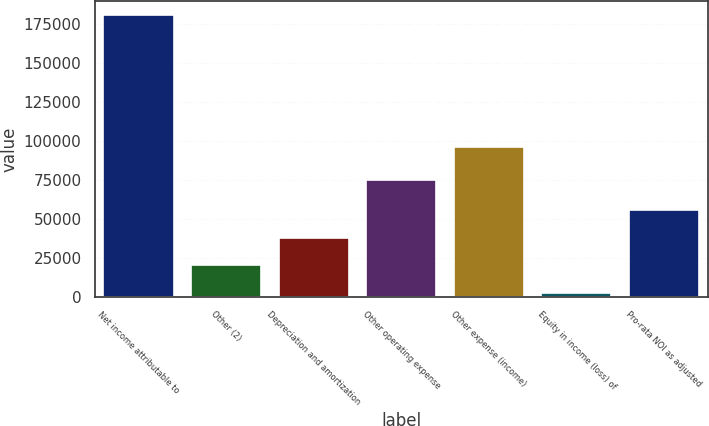Convert chart. <chart><loc_0><loc_0><loc_500><loc_500><bar_chart><fcel>Net income attributable to<fcel>Other (2)<fcel>Depreciation and amortization<fcel>Other operating expense<fcel>Other expense (income)<fcel>Equity in income (loss) of<fcel>Pro-rata NOI as adjusted<nl><fcel>180506<fcel>20049.5<fcel>37878<fcel>74590<fcel>96348<fcel>2221<fcel>55706.5<nl></chart> 